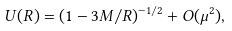Convert formula to latex. <formula><loc_0><loc_0><loc_500><loc_500>U ( R ) = ( 1 - 3 M / R ) ^ { - 1 / 2 } + O ( \mu ^ { 2 } ) ,</formula> 